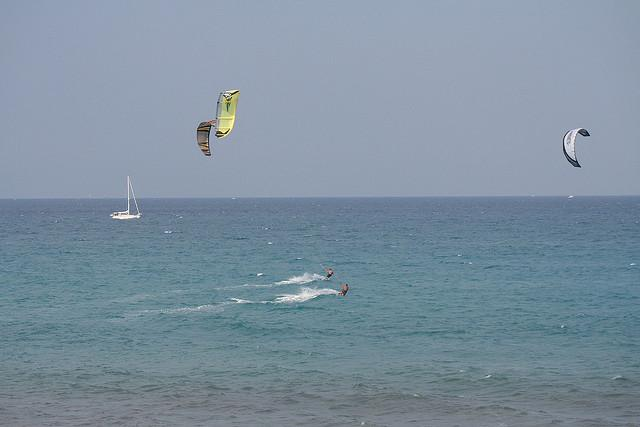What sport are the two people in the water participating in? jet skiing 